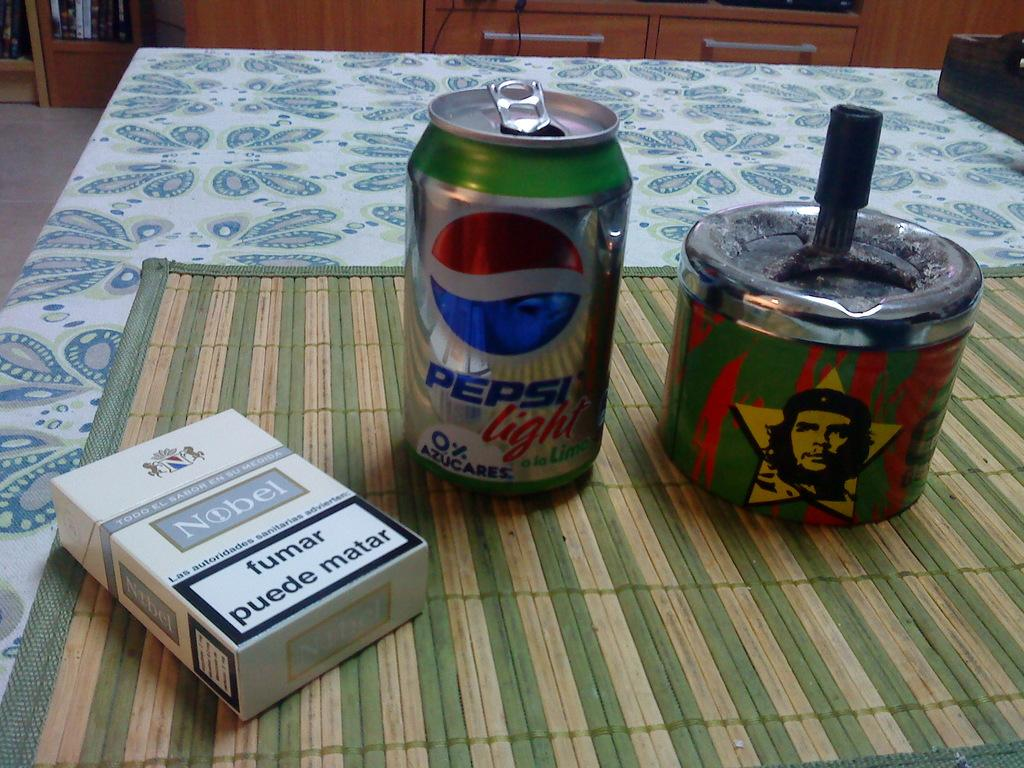<image>
Give a short and clear explanation of the subsequent image. a Pepsi can that is on a green surface 